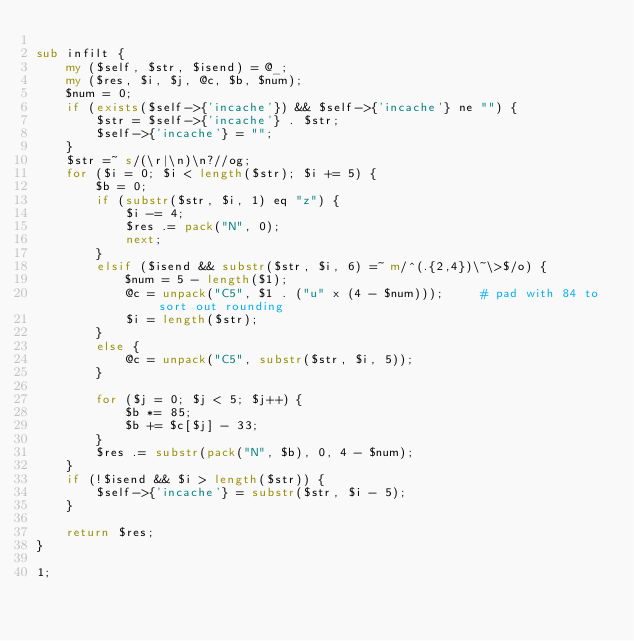Convert code to text. <code><loc_0><loc_0><loc_500><loc_500><_Perl_>
sub infilt {
    my ($self, $str, $isend) = @_;
    my ($res, $i, $j, @c, $b, $num);
    $num = 0;
    if (exists($self->{'incache'}) && $self->{'incache'} ne "") {
        $str = $self->{'incache'} . $str;
        $self->{'incache'} = "";
    }
    $str =~ s/(\r|\n)\n?//og;
    for ($i = 0; $i < length($str); $i += 5) {
        $b = 0;
        if (substr($str, $i, 1) eq "z") {
            $i -= 4;
            $res .= pack("N", 0);
            next;
        }
        elsif ($isend && substr($str, $i, 6) =~ m/^(.{2,4})\~\>$/o) {
            $num = 5 - length($1);
            @c = unpack("C5", $1 . ("u" x (4 - $num)));     # pad with 84 to sort out rounding
            $i = length($str);
        }
        else {
            @c = unpack("C5", substr($str, $i, 5));
        }

        for ($j = 0; $j < 5; $j++) {
            $b *= 85;
            $b += $c[$j] - 33;
        }
        $res .= substr(pack("N", $b), 0, 4 - $num);
    }
    if (!$isend && $i > length($str)) {
        $self->{'incache'} = substr($str, $i - 5);
    }

    return $res;
}

1;
</code> 